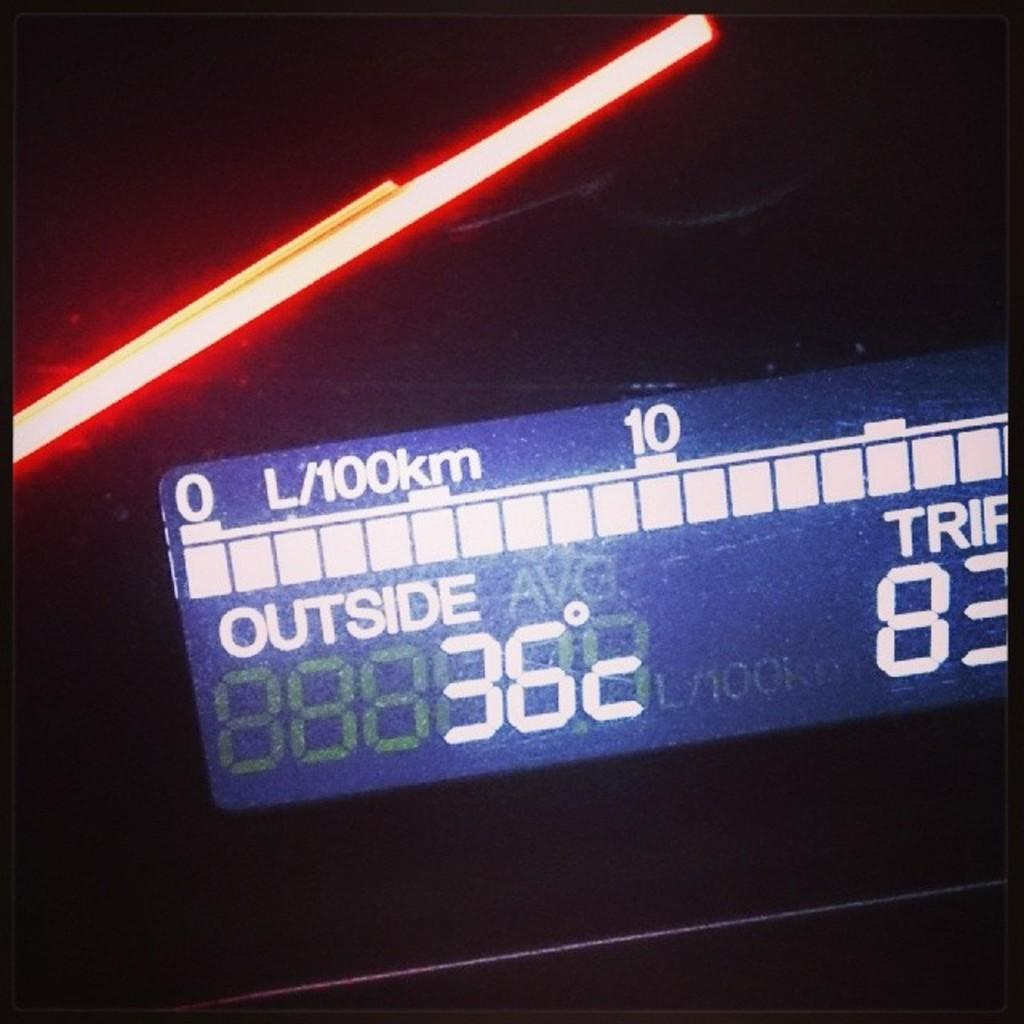<image>
Present a compact description of the photo's key features. A blue display that reads 36 degrees Celsius. 